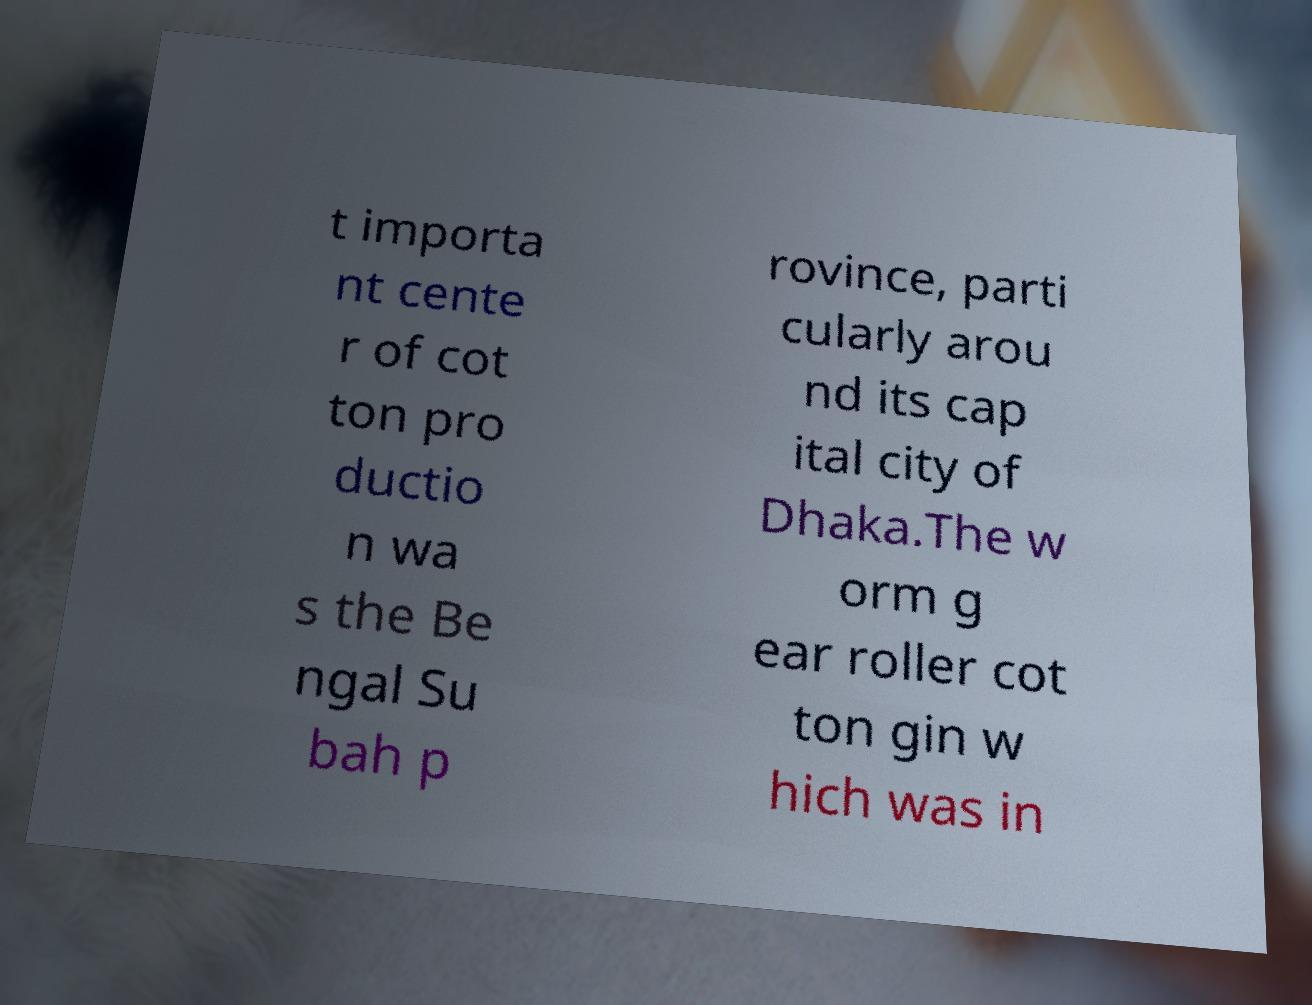There's text embedded in this image that I need extracted. Can you transcribe it verbatim? t importa nt cente r of cot ton pro ductio n wa s the Be ngal Su bah p rovince, parti cularly arou nd its cap ital city of Dhaka.The w orm g ear roller cot ton gin w hich was in 